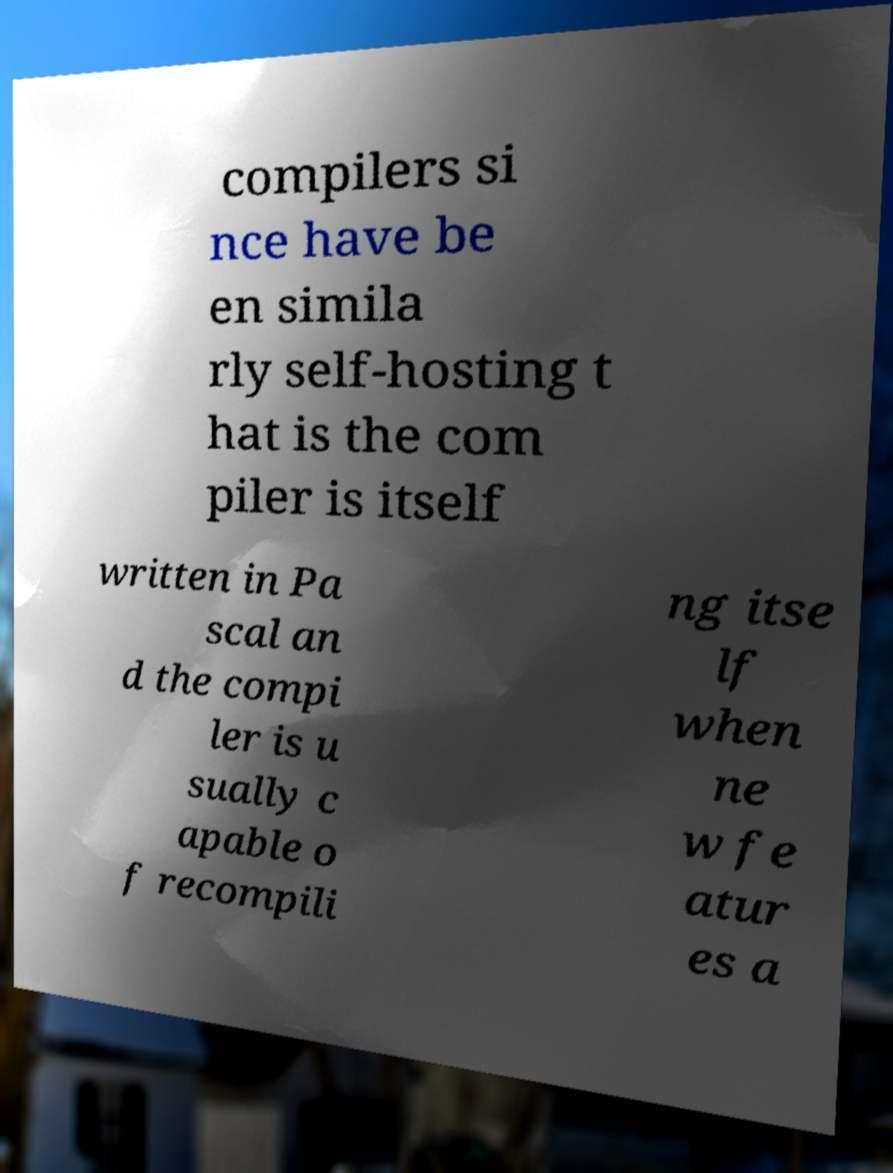Can you accurately transcribe the text from the provided image for me? compilers si nce have be en simila rly self-hosting t hat is the com piler is itself written in Pa scal an d the compi ler is u sually c apable o f recompili ng itse lf when ne w fe atur es a 